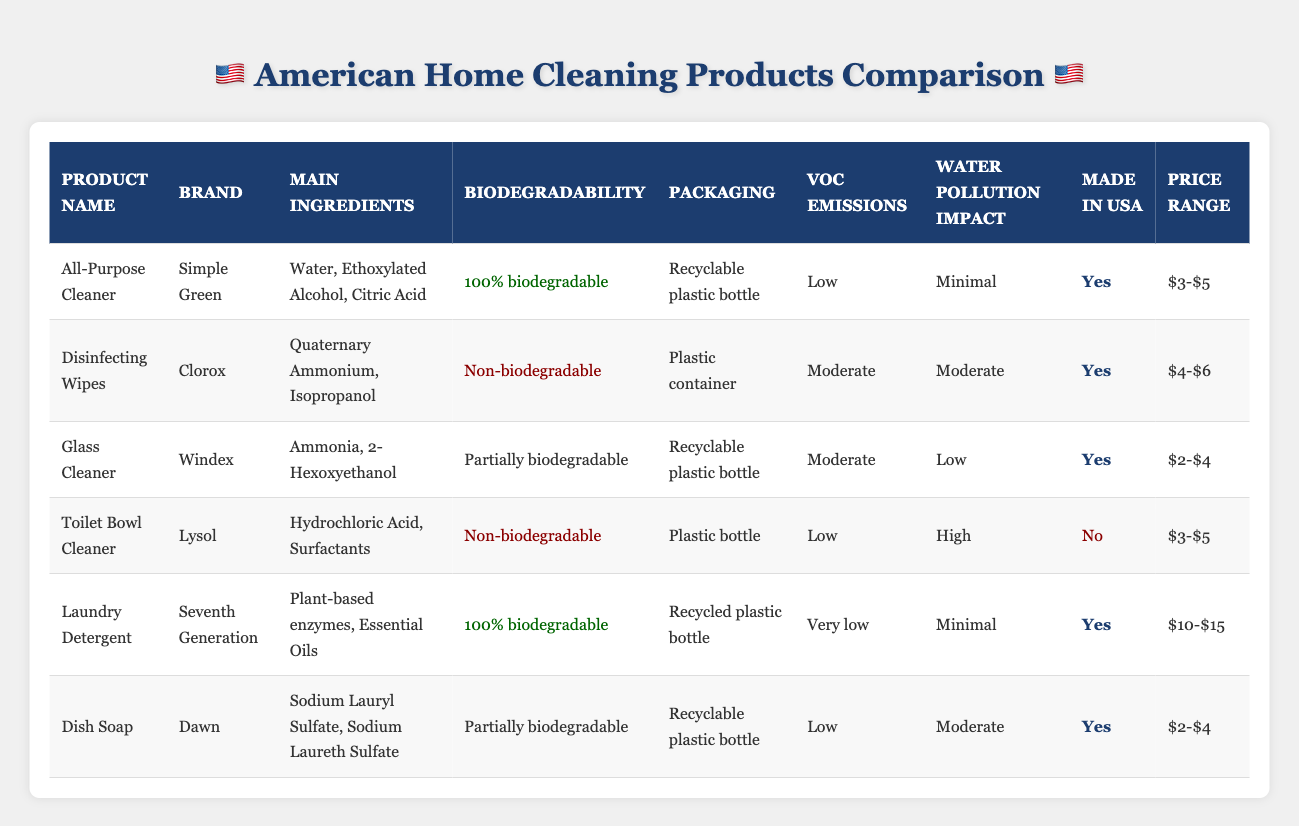What cleaning product has the lowest VOC emissions? The table shows the VOC emissions for each product. The "All-Purpose Cleaner" and "Toilet Bowl Cleaner" both have "Low" VOC emissions, but "Laundry Detergent" has "Very low" emissions, which is the least among them.
Answer: Laundry Detergent Which products are made in the USA? By checking the "Made in USA" column, we find that the products "All-Purpose Cleaner," "Disinfecting Wipes," "Glass Cleaner," "Laundry Detergent," and "Dish Soap" are marked "Yes." The "Toilet Bowl Cleaner" is not made in the USA.
Answer: All-Purpose Cleaner, Disinfecting Wipes, Glass Cleaner, Laundry Detergent, Dish Soap What is the price range for the "Seventh Generation" laundry detergent? The "Price Range" listed for "Seventh Generation" is mentioned directly in the table. It specifies that the price range is "$10-$15." This is a straightforward retrieval from the table.
Answer: $10-$15 How many products are biodegradable? The table lists two products as "100% biodegradable" (All-Purpose Cleaner and Laundry Detergent) and one as "Partially biodegradable" (Glass Cleaner). However, since “Partially biodegradable” does not meet the full criteria for biodegradability, we only count the two fully biodegradable ones.
Answer: 2 What is the impact of water pollution from the "Toilet Bowl Cleaner"? According to the table, the water pollution impact for the "Toilet Bowl Cleaner" is marked as "High." This is directly found in the "Water Pollution Impact" column for that specific product.
Answer: High Which product has the highest water pollution impact among those listed? The table shows that "Toilet Bowl Cleaner" has a "High" water pollution impact, while other products have "Minimal," "Low," or "Moderate." Thus, "Toilet Bowl Cleaner" is the product with the highest impact.
Answer: Toilet Bowl Cleaner Calculate the average price range for all products listed. The price ranges for the products can be interpreted numerically as follows: All-Purpose Cleaner ($4), Disinfecting Wipes ($5), Glass Cleaner ($3), Toilet Bowl Cleaner ($4), Laundry Detergent ($12.5), and Dish Soap ($3). The sum is $31.5 and there are 6 products, so the average price is $31.5 / 6 = $5.25.
Answer: $5.25 Are there any products that are non-biodegradable and made in the USA? Looking at the columns, "Disinfecting Wipes" is a non-biodegradable product made in the USA and "Toilet Bowl Cleaner" is non-biodegradable but not made in the USA. Thus, "Disinfecting Wipes" qualifies in both categories.
Answer: Yes How many cleaning products are partially biodegradable? The table indicates that there is one product labeled as partially biodegradable, and that's the "Dish Soap." This is a straightforward check from the "Biodegradability" column.
Answer: 1 